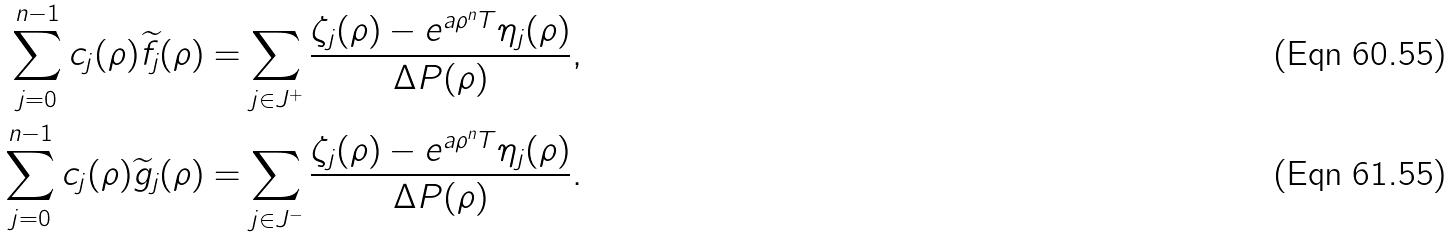<formula> <loc_0><loc_0><loc_500><loc_500>\sum _ { j = 0 } ^ { n - 1 } c _ { j } ( \rho ) \widetilde { f } _ { j } ( \rho ) & = \sum _ { j \in J ^ { + } } \frac { \zeta _ { j } ( \rho ) - e ^ { a \rho ^ { n } T } \eta _ { j } ( \rho ) } { \Delta P ( \rho ) } , \\ \sum _ { j = 0 } ^ { n - 1 } c _ { j } ( \rho ) \widetilde { g } _ { j } ( \rho ) & = \sum _ { j \in J ^ { - } } \frac { \zeta _ { j } ( \rho ) - e ^ { a \rho ^ { n } T } \eta _ { j } ( \rho ) } { \Delta P ( \rho ) } .</formula> 